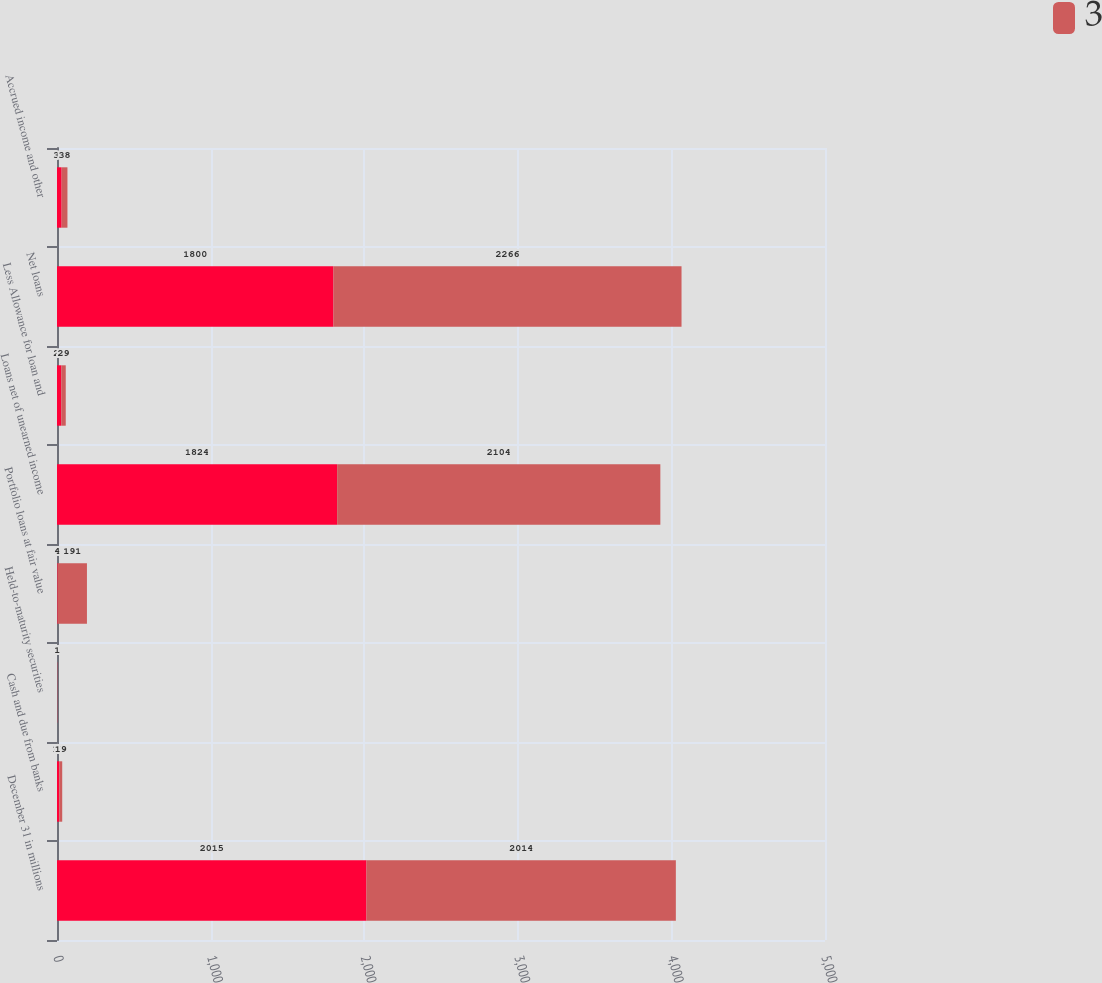Convert chart. <chart><loc_0><loc_0><loc_500><loc_500><stacked_bar_chart><ecel><fcel>December 31 in millions<fcel>Cash and due from banks<fcel>Held-to-maturity securities<fcel>Portfolio loans at fair value<fcel>Loans net of unearned income<fcel>Less Allowance for loan and<fcel>Net loans<fcel>Accrued income and other<nl><fcel>nan<fcel>2015<fcel>15<fcel>1<fcel>4<fcel>1824<fcel>28<fcel>1800<fcel>30<nl><fcel>3<fcel>2014<fcel>19<fcel>1<fcel>191<fcel>2104<fcel>29<fcel>2266<fcel>38<nl></chart> 